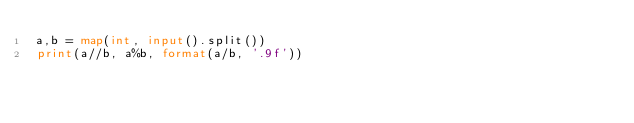Convert code to text. <code><loc_0><loc_0><loc_500><loc_500><_Python_>a,b = map(int, input().split())
print(a//b, a%b, format(a/b, '.9f'))</code> 